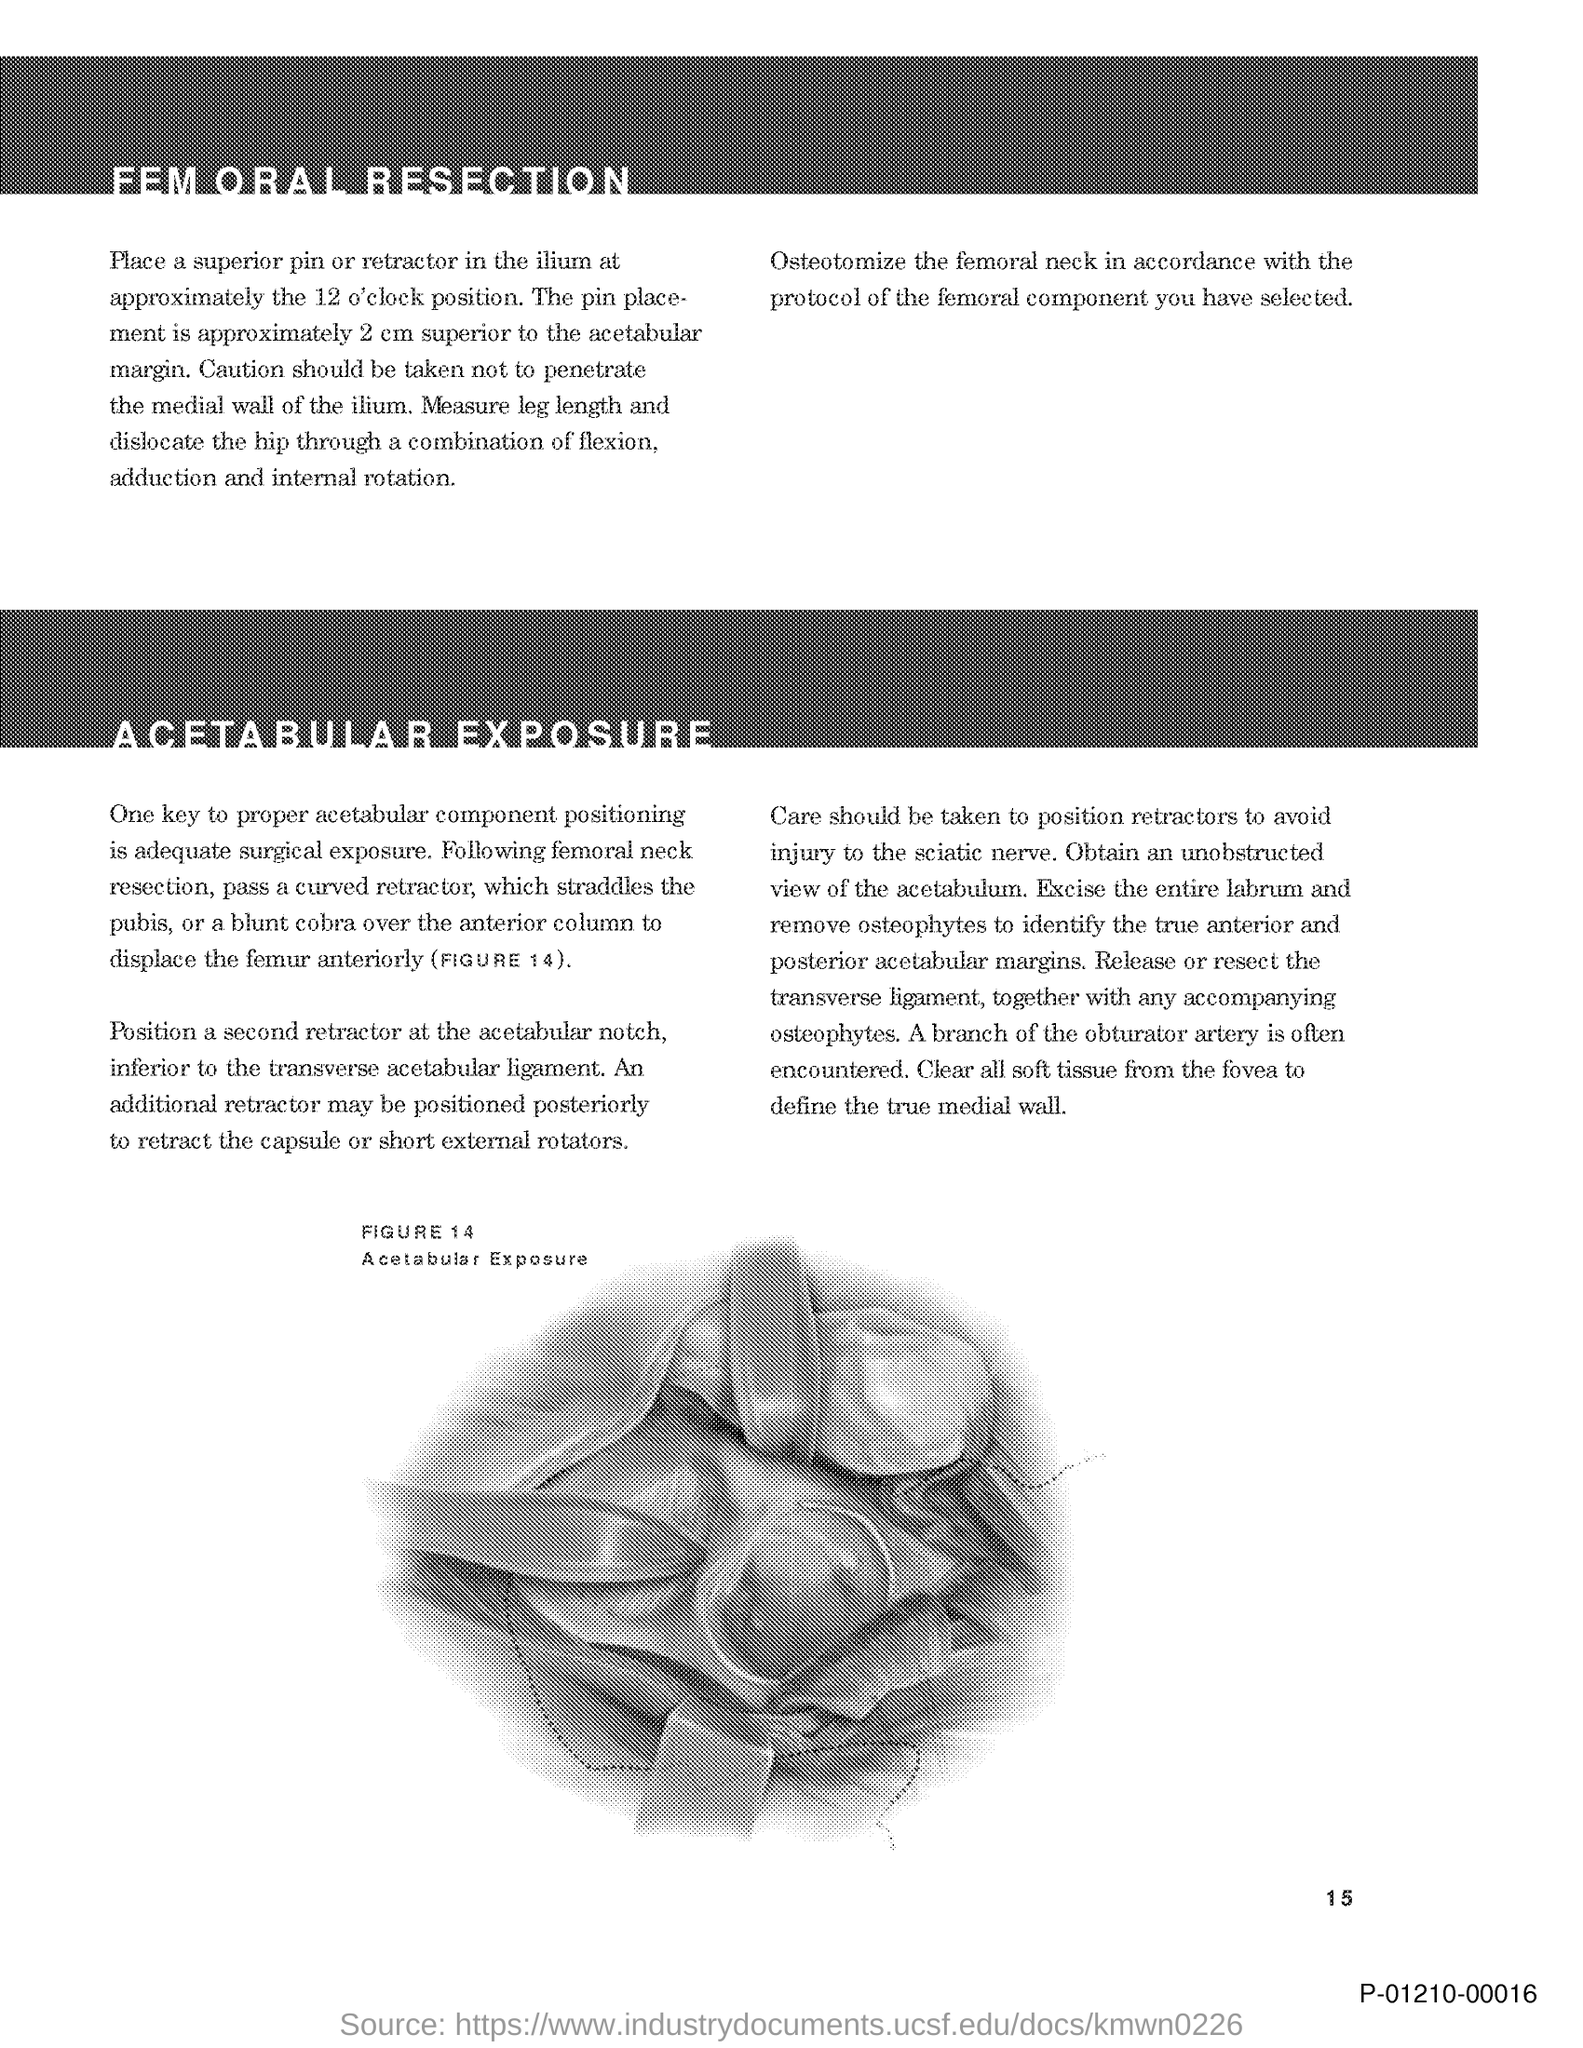Outline some significant characteristics in this image. Figure 14 in this document represents acetabular exposure. The page number mentioned in this document is 15.. 